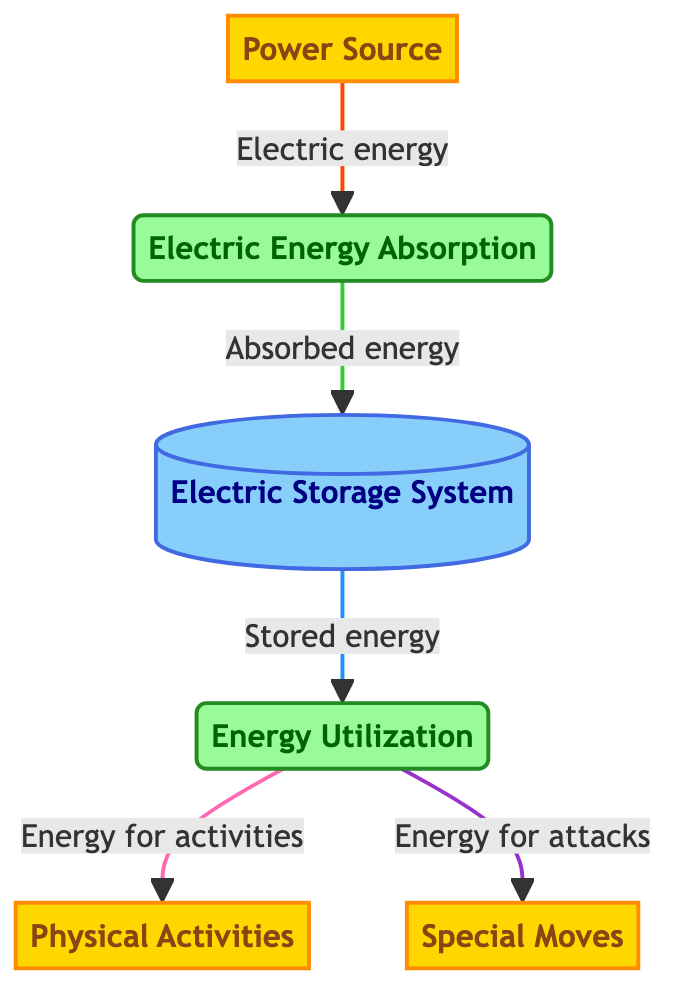What is the external entity that provides electric energy to Pikachu? The external entity labeled "Power Source" is the one that provides electric energy to Pikachu. It is clearly identified in the diagram and its function is to supply energy for absorption.
Answer: Power Source How many processes are present in the diagram? There are two processes shown in the diagram: "Electric Energy Absorption" and "Energy Utilization." To determine this, I count the nodes labeled as processes.
Answer: 2 Which process is responsible for absorbing electric energy? The process labeled "Electric Energy Absorption" is responsible for absorbing electric energy from the Power Source and is positioned prominently in the diagram.
Answer: Electric Energy Absorption What is the flow of energy from the Electric Storage System to the Energy Utilization process? The flow of energy from the "Electric Storage System" to "Energy Utilization" is described as "Stored energy." This connection indicates how energy is transferred for further use.
Answer: Stored energy Which external entities use the energy from the Energy Utilization process? The external entities that utilize energy from the "Energy Utilization" process are "Physical Activities" and "Special Moves." These are labeled clearly in the diagram as outcomes of energy utilization.
Answer: Physical Activities, Special Moves What is the relationship between Electric Energy Absorption and Electric Storage System? The relationship between "Electric Energy Absorption" and "Electric Storage System" is that absorbed energy flows into the storage system, marking a crucial step in energy management for Pikachu.
Answer: Absorbed energy How many external entities are depicted in the diagram? There are three external entities depicted in the diagram: "Power Source," "Physical Activities," and "Special Moves." I identify these nodes categorized as external entities in the diagram.
Answer: 3 What does the Energy Utilization process convert stored energy into? The "Energy Utilization" process converts stored energy into energy for activities and energy for attacks. I see these two flows branching out from the energy utilization process.
Answer: Energy for activities, energy for attacks 